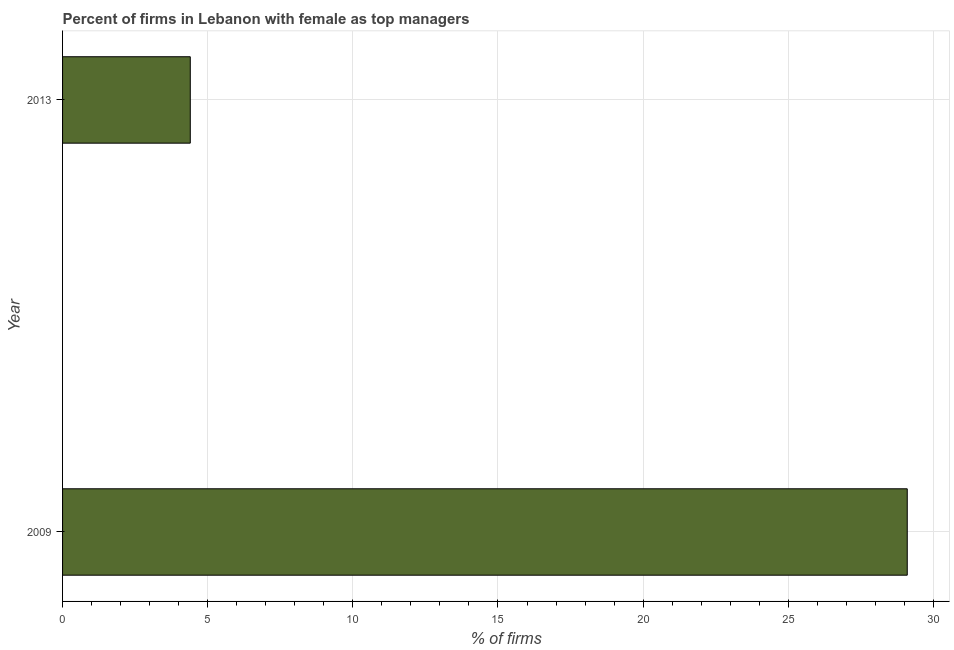Does the graph contain any zero values?
Your response must be concise. No. What is the title of the graph?
Keep it short and to the point. Percent of firms in Lebanon with female as top managers. What is the label or title of the X-axis?
Provide a short and direct response. % of firms. Across all years, what is the maximum percentage of firms with female as top manager?
Your response must be concise. 29.1. In which year was the percentage of firms with female as top manager maximum?
Provide a short and direct response. 2009. In which year was the percentage of firms with female as top manager minimum?
Offer a very short reply. 2013. What is the sum of the percentage of firms with female as top manager?
Offer a terse response. 33.5. What is the difference between the percentage of firms with female as top manager in 2009 and 2013?
Ensure brevity in your answer.  24.7. What is the average percentage of firms with female as top manager per year?
Ensure brevity in your answer.  16.75. What is the median percentage of firms with female as top manager?
Your response must be concise. 16.75. What is the ratio of the percentage of firms with female as top manager in 2009 to that in 2013?
Provide a succinct answer. 6.61. In how many years, is the percentage of firms with female as top manager greater than the average percentage of firms with female as top manager taken over all years?
Ensure brevity in your answer.  1. Are all the bars in the graph horizontal?
Your response must be concise. Yes. How many years are there in the graph?
Keep it short and to the point. 2. What is the difference between two consecutive major ticks on the X-axis?
Your answer should be very brief. 5. What is the % of firms in 2009?
Offer a very short reply. 29.1. What is the difference between the % of firms in 2009 and 2013?
Give a very brief answer. 24.7. What is the ratio of the % of firms in 2009 to that in 2013?
Provide a succinct answer. 6.61. 